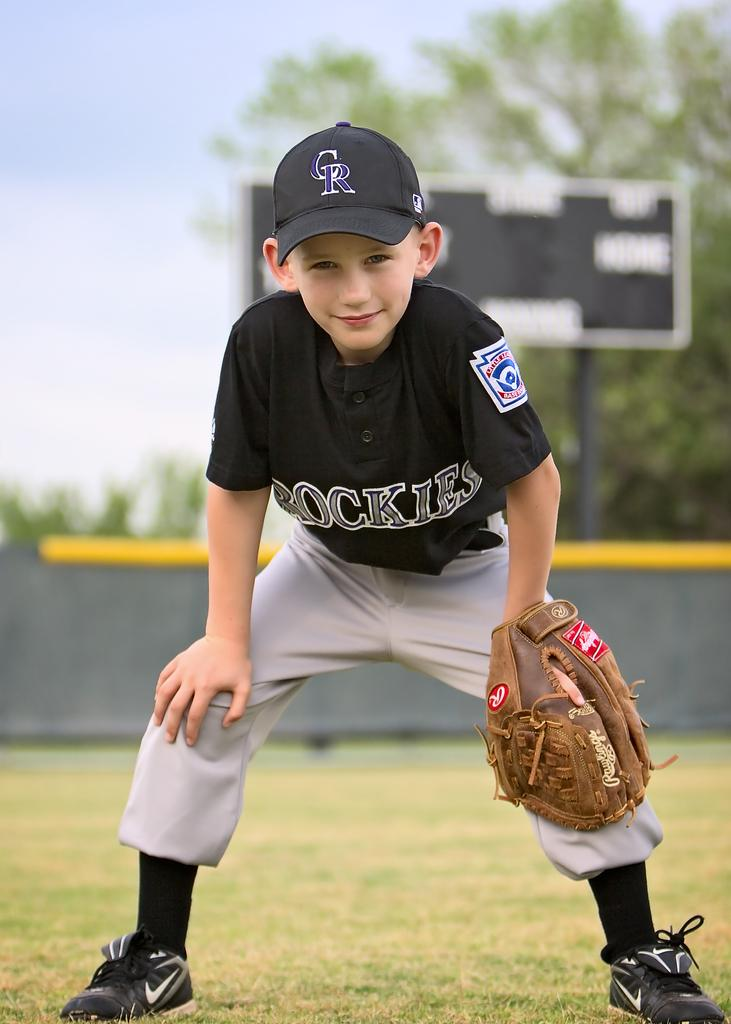<image>
Summarize the visual content of the image. The young boy has the letters CR written on his hat. 